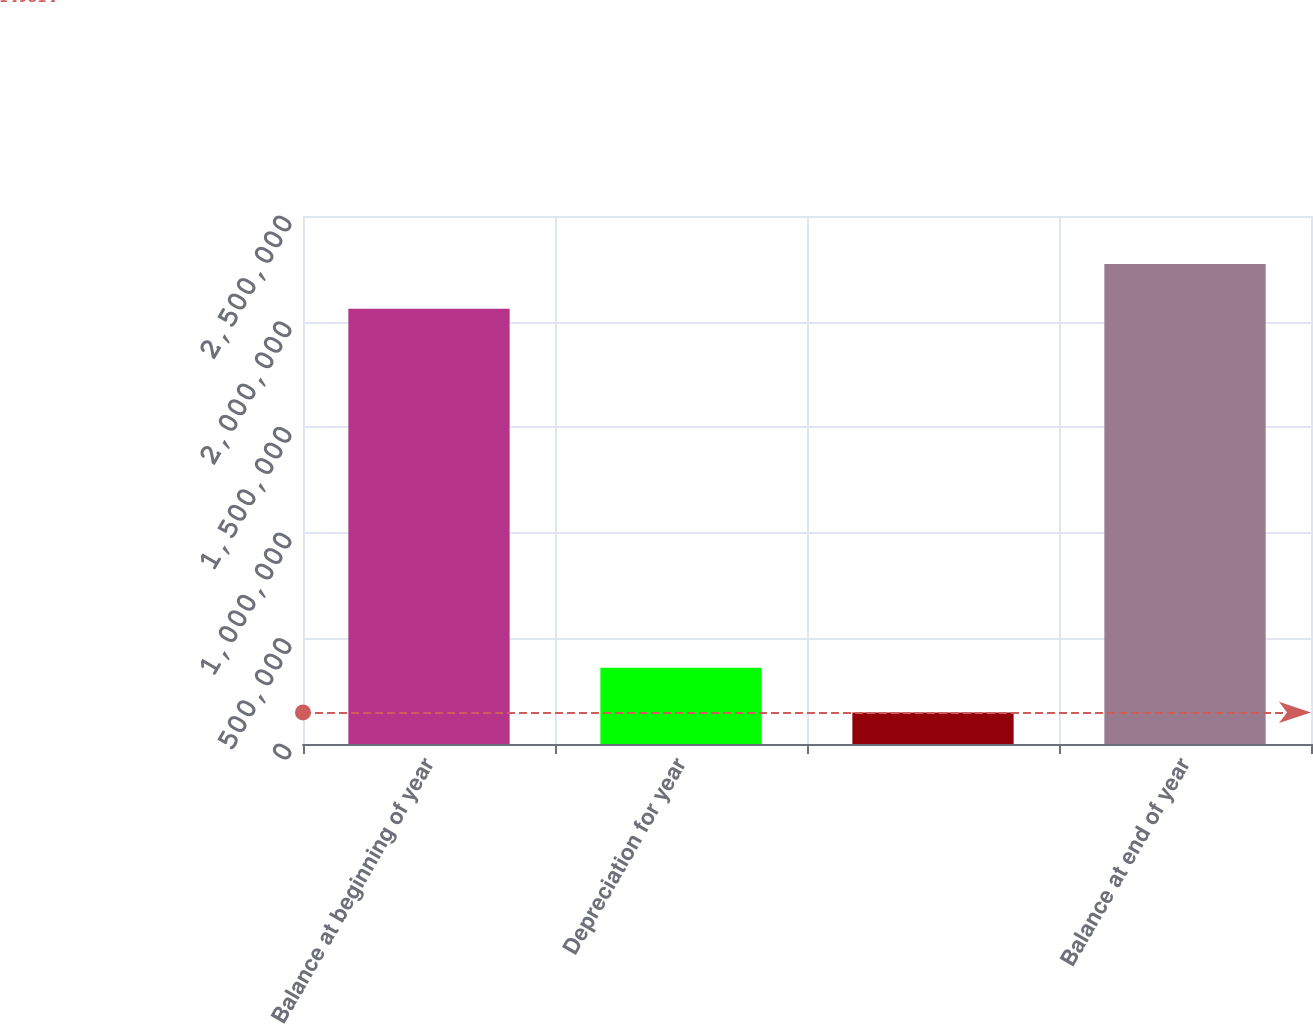Convert chart. <chart><loc_0><loc_0><loc_500><loc_500><bar_chart><fcel>Balance at beginning of year<fcel>Depreciation for year<fcel>Unnamed: 2<fcel>Balance at end of year<nl><fcel>2.06071e+06<fcel>361032<fcel>149514<fcel>2.27222e+06<nl></chart> 